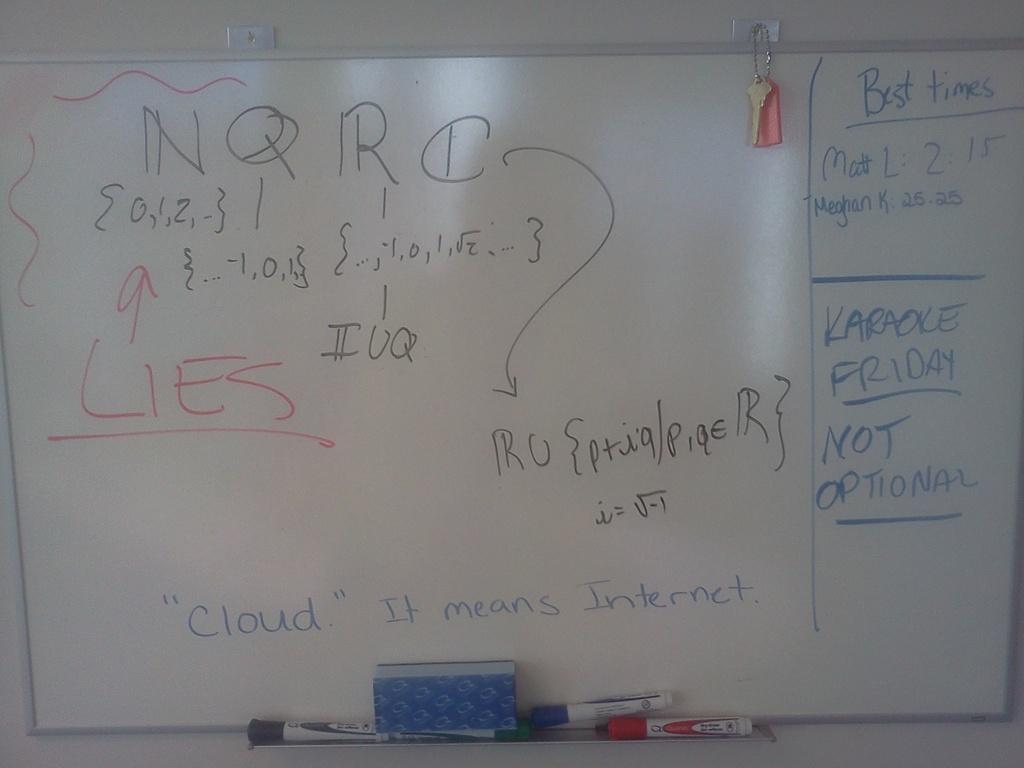Is this about the internet?
Offer a very short reply. Yes. What does it say in red?
Offer a terse response. Lies. 